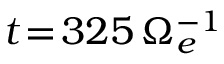Convert formula to latex. <formula><loc_0><loc_0><loc_500><loc_500>t \, = \, 3 2 5 \, \Omega _ { e } ^ { - 1 }</formula> 